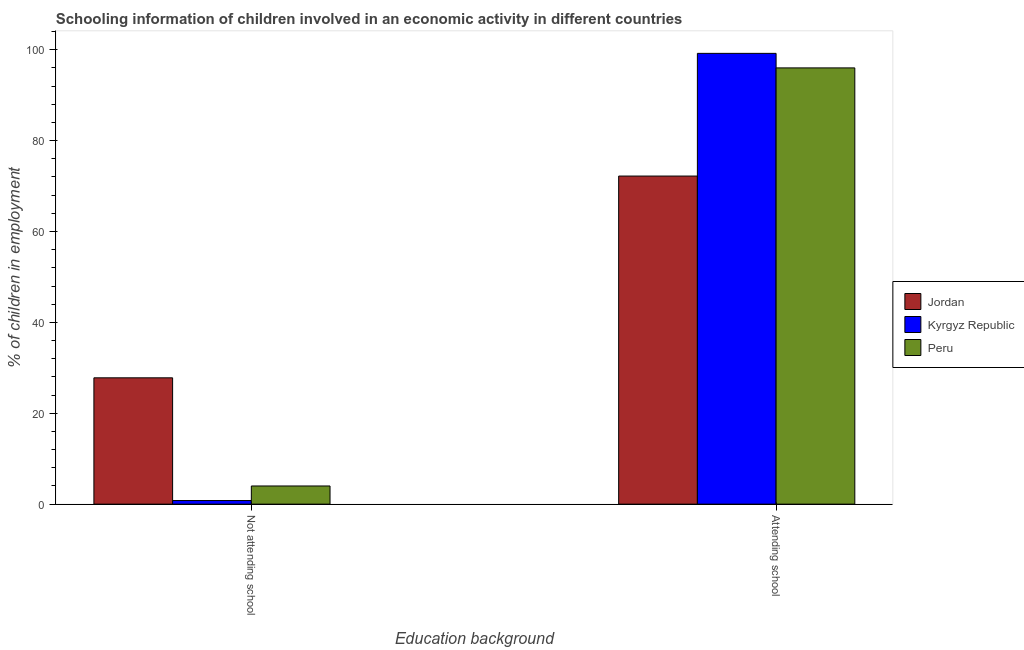How many different coloured bars are there?
Provide a short and direct response. 3. How many bars are there on the 1st tick from the left?
Provide a short and direct response. 3. What is the label of the 2nd group of bars from the left?
Give a very brief answer. Attending school. Across all countries, what is the maximum percentage of employed children who are not attending school?
Offer a very short reply. 27.8. Across all countries, what is the minimum percentage of employed children who are attending school?
Keep it short and to the point. 72.2. In which country was the percentage of employed children who are attending school maximum?
Offer a very short reply. Kyrgyz Republic. In which country was the percentage of employed children who are attending school minimum?
Keep it short and to the point. Jordan. What is the total percentage of employed children who are attending school in the graph?
Give a very brief answer. 267.4. What is the difference between the percentage of employed children who are not attending school in Jordan and that in Kyrgyz Republic?
Make the answer very short. 27. What is the difference between the percentage of employed children who are attending school in Peru and the percentage of employed children who are not attending school in Jordan?
Your answer should be compact. 68.2. What is the average percentage of employed children who are attending school per country?
Ensure brevity in your answer.  89.13. What is the difference between the percentage of employed children who are attending school and percentage of employed children who are not attending school in Jordan?
Make the answer very short. 44.4. In how many countries, is the percentage of employed children who are attending school greater than 16 %?
Ensure brevity in your answer.  3. What is the ratio of the percentage of employed children who are attending school in Jordan to that in Kyrgyz Republic?
Offer a very short reply. 0.73. Is the percentage of employed children who are attending school in Kyrgyz Republic less than that in Peru?
Your answer should be very brief. No. What does the 2nd bar from the left in Attending school represents?
Ensure brevity in your answer.  Kyrgyz Republic. How many bars are there?
Provide a short and direct response. 6. Are all the bars in the graph horizontal?
Offer a very short reply. No. What is the difference between two consecutive major ticks on the Y-axis?
Your answer should be compact. 20. Does the graph contain any zero values?
Your answer should be very brief. No. Does the graph contain grids?
Offer a very short reply. No. How are the legend labels stacked?
Provide a succinct answer. Vertical. What is the title of the graph?
Offer a terse response. Schooling information of children involved in an economic activity in different countries. Does "Kazakhstan" appear as one of the legend labels in the graph?
Give a very brief answer. No. What is the label or title of the X-axis?
Offer a terse response. Education background. What is the label or title of the Y-axis?
Keep it short and to the point. % of children in employment. What is the % of children in employment in Jordan in Not attending school?
Ensure brevity in your answer.  27.8. What is the % of children in employment of Kyrgyz Republic in Not attending school?
Your answer should be very brief. 0.8. What is the % of children in employment of Peru in Not attending school?
Your answer should be very brief. 4. What is the % of children in employment of Jordan in Attending school?
Your response must be concise. 72.2. What is the % of children in employment of Kyrgyz Republic in Attending school?
Make the answer very short. 99.2. What is the % of children in employment in Peru in Attending school?
Provide a succinct answer. 96. Across all Education background, what is the maximum % of children in employment in Jordan?
Provide a short and direct response. 72.2. Across all Education background, what is the maximum % of children in employment of Kyrgyz Republic?
Your answer should be very brief. 99.2. Across all Education background, what is the maximum % of children in employment in Peru?
Make the answer very short. 96. Across all Education background, what is the minimum % of children in employment of Jordan?
Offer a terse response. 27.8. Across all Education background, what is the minimum % of children in employment of Kyrgyz Republic?
Make the answer very short. 0.8. What is the total % of children in employment of Jordan in the graph?
Keep it short and to the point. 100. What is the total % of children in employment in Peru in the graph?
Give a very brief answer. 100. What is the difference between the % of children in employment of Jordan in Not attending school and that in Attending school?
Your answer should be compact. -44.4. What is the difference between the % of children in employment in Kyrgyz Republic in Not attending school and that in Attending school?
Offer a very short reply. -98.4. What is the difference between the % of children in employment of Peru in Not attending school and that in Attending school?
Offer a terse response. -92. What is the difference between the % of children in employment of Jordan in Not attending school and the % of children in employment of Kyrgyz Republic in Attending school?
Provide a short and direct response. -71.4. What is the difference between the % of children in employment in Jordan in Not attending school and the % of children in employment in Peru in Attending school?
Make the answer very short. -68.2. What is the difference between the % of children in employment in Kyrgyz Republic in Not attending school and the % of children in employment in Peru in Attending school?
Keep it short and to the point. -95.2. What is the average % of children in employment of Kyrgyz Republic per Education background?
Your response must be concise. 50. What is the average % of children in employment in Peru per Education background?
Ensure brevity in your answer.  50. What is the difference between the % of children in employment of Jordan and % of children in employment of Kyrgyz Republic in Not attending school?
Give a very brief answer. 27. What is the difference between the % of children in employment in Jordan and % of children in employment in Peru in Not attending school?
Keep it short and to the point. 23.8. What is the difference between the % of children in employment in Kyrgyz Republic and % of children in employment in Peru in Not attending school?
Your answer should be very brief. -3.2. What is the difference between the % of children in employment in Jordan and % of children in employment in Peru in Attending school?
Provide a succinct answer. -23.8. What is the ratio of the % of children in employment of Jordan in Not attending school to that in Attending school?
Make the answer very short. 0.39. What is the ratio of the % of children in employment in Kyrgyz Republic in Not attending school to that in Attending school?
Keep it short and to the point. 0.01. What is the ratio of the % of children in employment in Peru in Not attending school to that in Attending school?
Give a very brief answer. 0.04. What is the difference between the highest and the second highest % of children in employment of Jordan?
Offer a very short reply. 44.4. What is the difference between the highest and the second highest % of children in employment in Kyrgyz Republic?
Keep it short and to the point. 98.4. What is the difference between the highest and the second highest % of children in employment of Peru?
Ensure brevity in your answer.  92. What is the difference between the highest and the lowest % of children in employment of Jordan?
Give a very brief answer. 44.4. What is the difference between the highest and the lowest % of children in employment in Kyrgyz Republic?
Offer a terse response. 98.4. What is the difference between the highest and the lowest % of children in employment of Peru?
Your response must be concise. 92. 